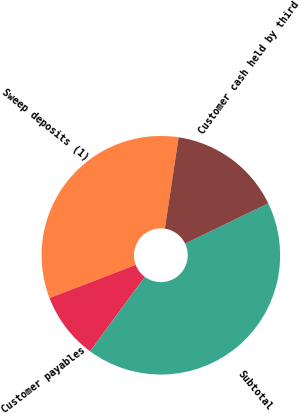Convert chart to OTSL. <chart><loc_0><loc_0><loc_500><loc_500><pie_chart><fcel>Sweep deposits (1)<fcel>Customer payables<fcel>Subtotal<fcel>Customer cash held by third<nl><fcel>33.22%<fcel>9.05%<fcel>42.27%<fcel>15.45%<nl></chart> 